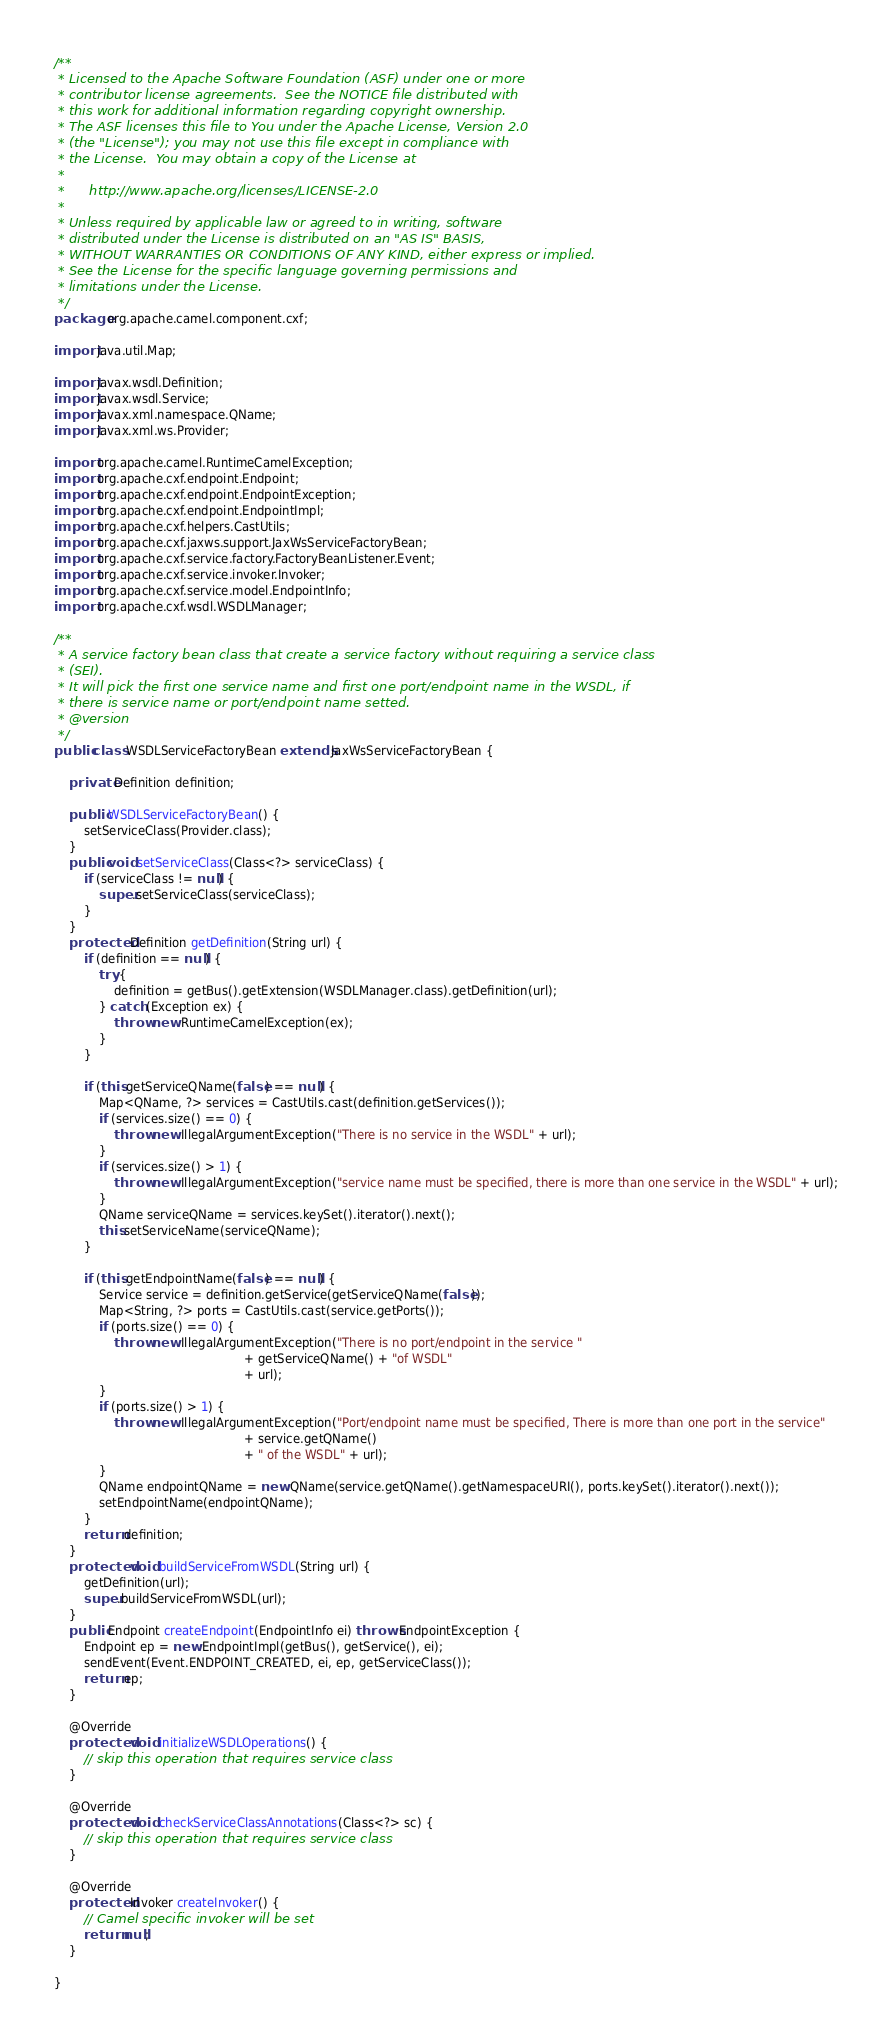Convert code to text. <code><loc_0><loc_0><loc_500><loc_500><_Java_>/**
 * Licensed to the Apache Software Foundation (ASF) under one or more
 * contributor license agreements.  See the NOTICE file distributed with
 * this work for additional information regarding copyright ownership.
 * The ASF licenses this file to You under the Apache License, Version 2.0
 * (the "License"); you may not use this file except in compliance with
 * the License.  You may obtain a copy of the License at
 *
 *      http://www.apache.org/licenses/LICENSE-2.0
 *
 * Unless required by applicable law or agreed to in writing, software
 * distributed under the License is distributed on an "AS IS" BASIS,
 * WITHOUT WARRANTIES OR CONDITIONS OF ANY KIND, either express or implied.
 * See the License for the specific language governing permissions and
 * limitations under the License.
 */
package org.apache.camel.component.cxf;

import java.util.Map;

import javax.wsdl.Definition;
import javax.wsdl.Service;
import javax.xml.namespace.QName;
import javax.xml.ws.Provider;

import org.apache.camel.RuntimeCamelException;
import org.apache.cxf.endpoint.Endpoint;
import org.apache.cxf.endpoint.EndpointException;
import org.apache.cxf.endpoint.EndpointImpl;
import org.apache.cxf.helpers.CastUtils;
import org.apache.cxf.jaxws.support.JaxWsServiceFactoryBean;
import org.apache.cxf.service.factory.FactoryBeanListener.Event;
import org.apache.cxf.service.invoker.Invoker;
import org.apache.cxf.service.model.EndpointInfo;
import org.apache.cxf.wsdl.WSDLManager;

/**
 * A service factory bean class that create a service factory without requiring a service class
 * (SEI).
 * It will pick the first one service name and first one port/endpoint name in the WSDL, if 
 * there is service name or port/endpoint name setted.
 * @version 
 */
public class WSDLServiceFactoryBean extends JaxWsServiceFactoryBean {
    
    private Definition definition;

    public WSDLServiceFactoryBean() {
        setServiceClass(Provider.class);
    }
    public void setServiceClass(Class<?> serviceClass) {
        if (serviceClass != null) {
            super.setServiceClass(serviceClass);
        }
    }
    protected Definition getDefinition(String url) {
        if (definition == null) {
            try {
                definition = getBus().getExtension(WSDLManager.class).getDefinition(url);
            } catch (Exception ex) {
                throw new RuntimeCamelException(ex);
            }
        } 
        
        if (this.getServiceQName(false) == null) {
            Map<QName, ?> services = CastUtils.cast(definition.getServices());
            if (services.size() == 0) {
                throw new IllegalArgumentException("There is no service in the WSDL" + url);
            }
            if (services.size() > 1) {
                throw new IllegalArgumentException("service name must be specified, there is more than one service in the WSDL" + url);
            }
            QName serviceQName = services.keySet().iterator().next();
            this.setServiceName(serviceQName);
        }

        if (this.getEndpointName(false) == null) {
            Service service = definition.getService(getServiceQName(false));
            Map<String, ?> ports = CastUtils.cast(service.getPorts());
            if (ports.size() == 0) {
                throw new IllegalArgumentException("There is no port/endpoint in the service "
                                                   + getServiceQName() + "of WSDL"
                                                   + url);
            }
            if (ports.size() > 1) {
                throw new IllegalArgumentException("Port/endpoint name must be specified, There is more than one port in the service"
                                                   + service.getQName()
                                                   + " of the WSDL" + url);
            }
            QName endpointQName = new QName(service.getQName().getNamespaceURI(), ports.keySet().iterator().next());
            setEndpointName(endpointQName);
        }
        return definition;
    }
    protected void buildServiceFromWSDL(String url) {
        getDefinition(url);
        super.buildServiceFromWSDL(url);
    }
    public Endpoint createEndpoint(EndpointInfo ei) throws EndpointException {
        Endpoint ep = new EndpointImpl(getBus(), getService(), ei);
        sendEvent(Event.ENDPOINT_CREATED, ei, ep, getServiceClass());
        return ep;
    }

    @Override
    protected void initializeWSDLOperations() {
        // skip this operation that requires service class
    }
    
    @Override
    protected void checkServiceClassAnnotations(Class<?> sc) {
        // skip this operation that requires service class
    }
    
    @Override
    protected Invoker createInvoker() {
        // Camel specific invoker will be set 
        return null;
    }

}
</code> 